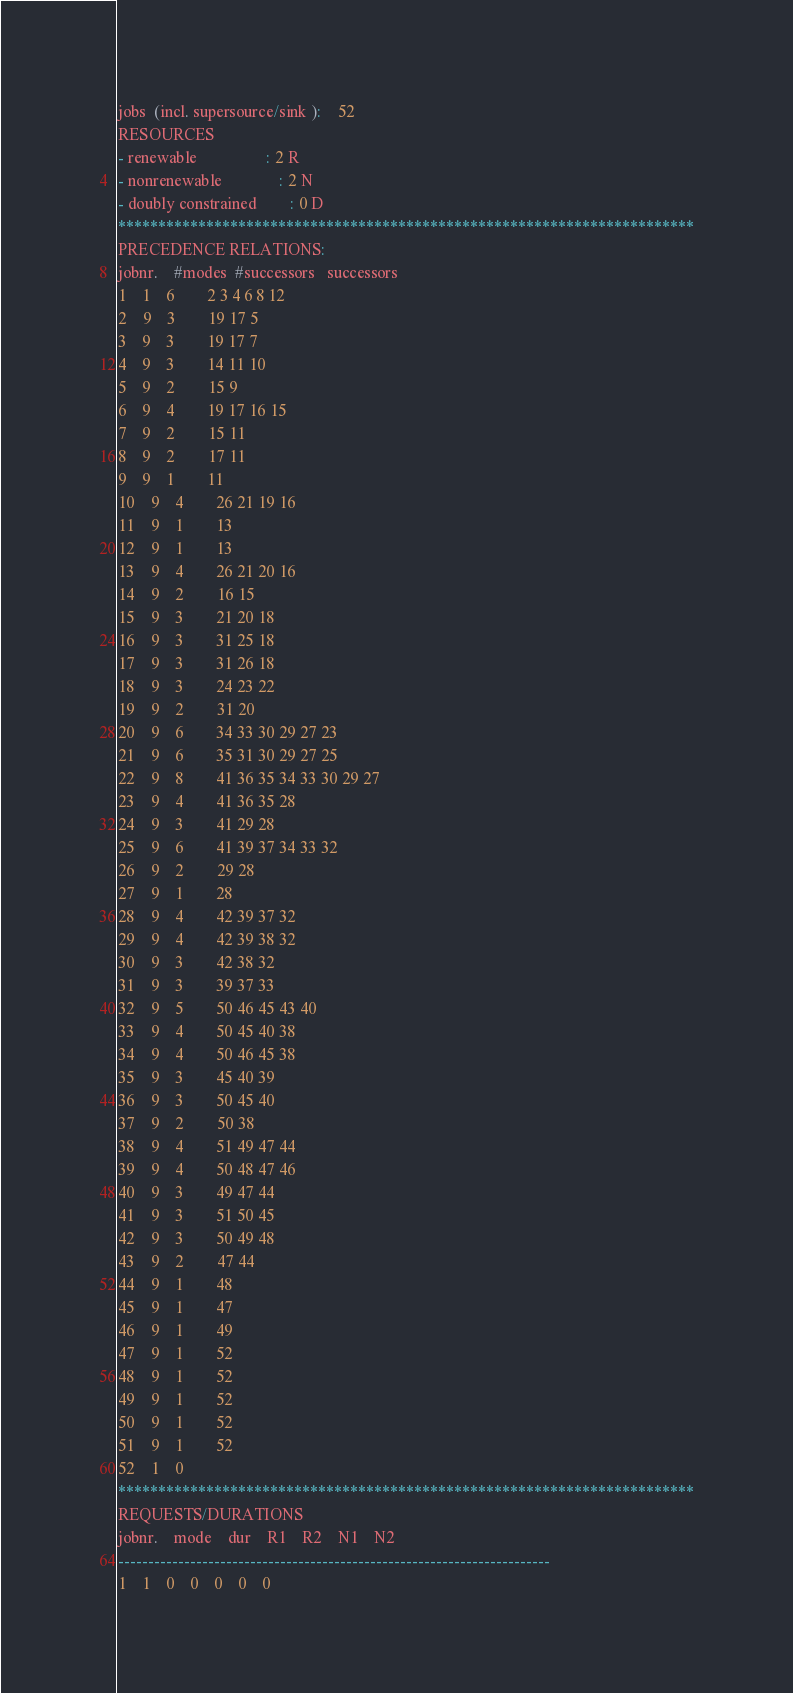<code> <loc_0><loc_0><loc_500><loc_500><_ObjectiveC_>jobs  (incl. supersource/sink ):	52
RESOURCES
- renewable                 : 2 R
- nonrenewable              : 2 N
- doubly constrained        : 0 D
************************************************************************
PRECEDENCE RELATIONS:
jobnr.    #modes  #successors   successors
1	1	6		2 3 4 6 8 12 
2	9	3		19 17 5 
3	9	3		19 17 7 
4	9	3		14 11 10 
5	9	2		15 9 
6	9	4		19 17 16 15 
7	9	2		15 11 
8	9	2		17 11 
9	9	1		11 
10	9	4		26 21 19 16 
11	9	1		13 
12	9	1		13 
13	9	4		26 21 20 16 
14	9	2		16 15 
15	9	3		21 20 18 
16	9	3		31 25 18 
17	9	3		31 26 18 
18	9	3		24 23 22 
19	9	2		31 20 
20	9	6		34 33 30 29 27 23 
21	9	6		35 31 30 29 27 25 
22	9	8		41 36 35 34 33 30 29 27 
23	9	4		41 36 35 28 
24	9	3		41 29 28 
25	9	6		41 39 37 34 33 32 
26	9	2		29 28 
27	9	1		28 
28	9	4		42 39 37 32 
29	9	4		42 39 38 32 
30	9	3		42 38 32 
31	9	3		39 37 33 
32	9	5		50 46 45 43 40 
33	9	4		50 45 40 38 
34	9	4		50 46 45 38 
35	9	3		45 40 39 
36	9	3		50 45 40 
37	9	2		50 38 
38	9	4		51 49 47 44 
39	9	4		50 48 47 46 
40	9	3		49 47 44 
41	9	3		51 50 45 
42	9	3		50 49 48 
43	9	2		47 44 
44	9	1		48 
45	9	1		47 
46	9	1		49 
47	9	1		52 
48	9	1		52 
49	9	1		52 
50	9	1		52 
51	9	1		52 
52	1	0		
************************************************************************
REQUESTS/DURATIONS
jobnr.	mode	dur	R1	R2	N1	N2	
------------------------------------------------------------------------
1	1	0	0	0	0	0	</code> 